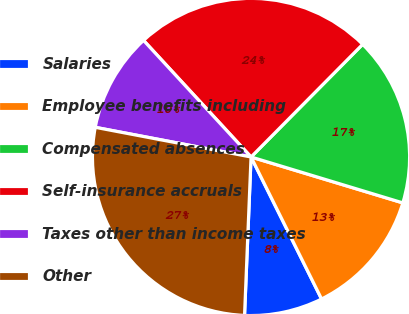Convert chart to OTSL. <chart><loc_0><loc_0><loc_500><loc_500><pie_chart><fcel>Salaries<fcel>Employee benefits including<fcel>Compensated absences<fcel>Self-insurance accruals<fcel>Taxes other than income taxes<fcel>Other<nl><fcel>7.99%<fcel>12.99%<fcel>17.25%<fcel>24.28%<fcel>10.15%<fcel>27.34%<nl></chart> 